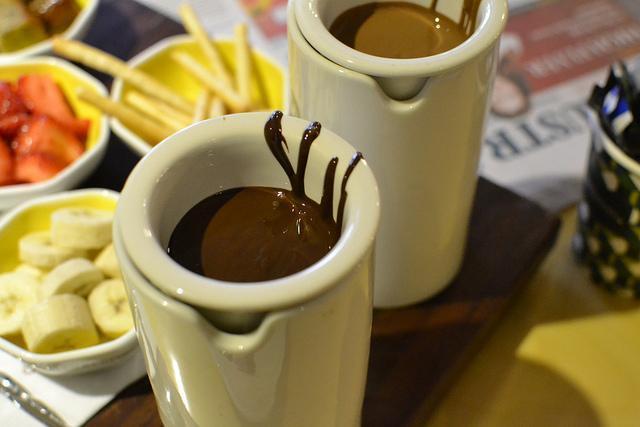How many cups are there?
Give a very brief answer. 3. How many bowls are there?
Give a very brief answer. 5. 